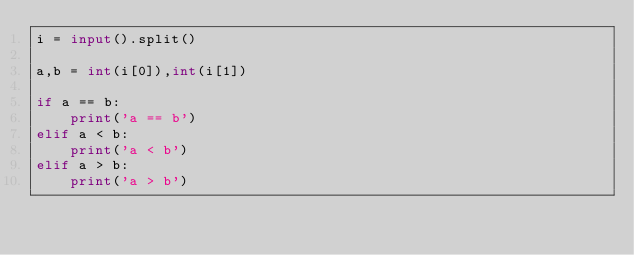Convert code to text. <code><loc_0><loc_0><loc_500><loc_500><_Python_>i = input().split()

a,b = int(i[0]),int(i[1])

if a == b:
    print('a == b')
elif a < b:
    print('a < b')
elif a > b:
    print('a > b')
</code> 